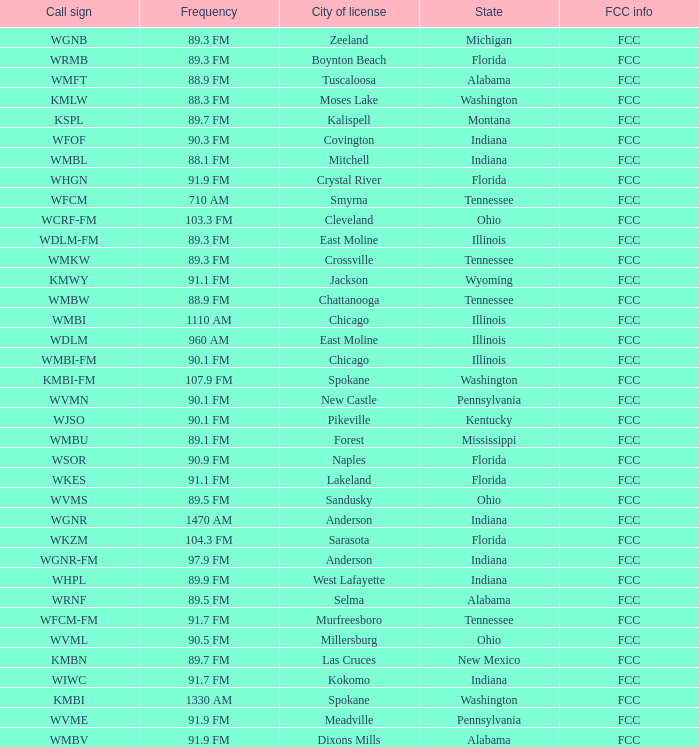What state is the radio station in that has a frequency of 90.1 FM and a city license in New Castle? Pennsylvania. 